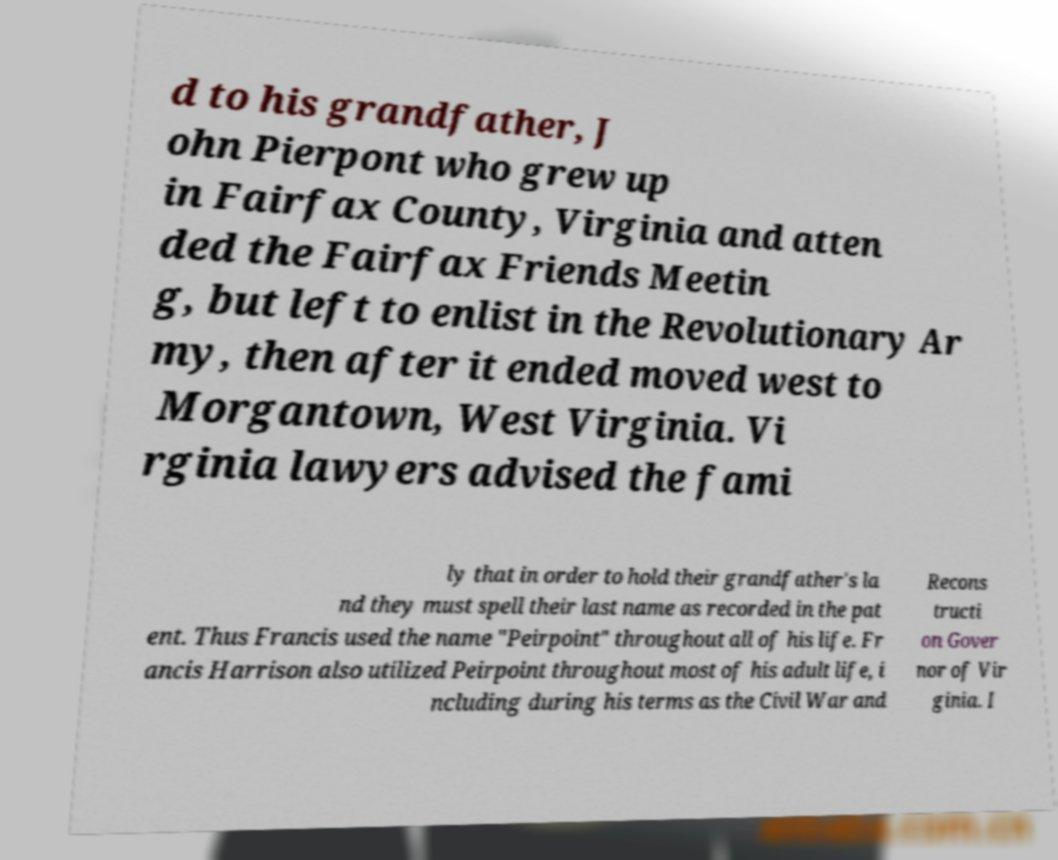Can you read and provide the text displayed in the image?This photo seems to have some interesting text. Can you extract and type it out for me? d to his grandfather, J ohn Pierpont who grew up in Fairfax County, Virginia and atten ded the Fairfax Friends Meetin g, but left to enlist in the Revolutionary Ar my, then after it ended moved west to Morgantown, West Virginia. Vi rginia lawyers advised the fami ly that in order to hold their grandfather's la nd they must spell their last name as recorded in the pat ent. Thus Francis used the name "Peirpoint" throughout all of his life. Fr ancis Harrison also utilized Peirpoint throughout most of his adult life, i ncluding during his terms as the Civil War and Recons tructi on Gover nor of Vir ginia. I 